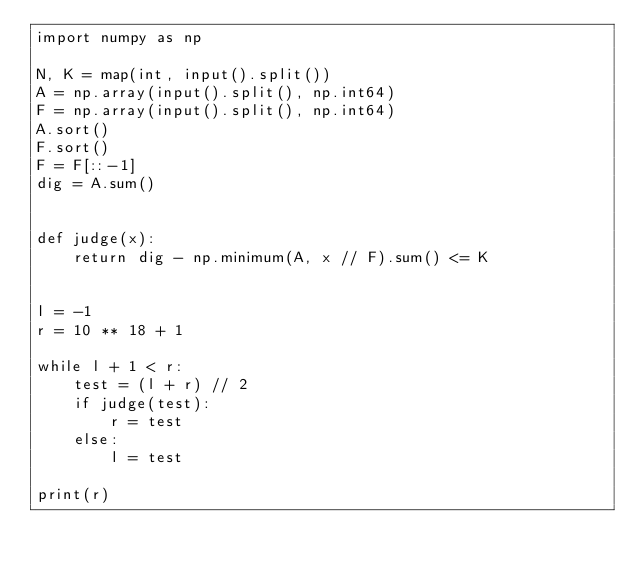<code> <loc_0><loc_0><loc_500><loc_500><_Python_>import numpy as np

N, K = map(int, input().split())
A = np.array(input().split(), np.int64)
F = np.array(input().split(), np.int64)
A.sort()
F.sort()
F = F[::-1]
dig = A.sum()


def judge(x):
    return dig - np.minimum(A, x // F).sum() <= K


l = -1
r = 10 ** 18 + 1

while l + 1 < r:
    test = (l + r) // 2
    if judge(test):
        r = test
    else:
        l = test

print(r)</code> 